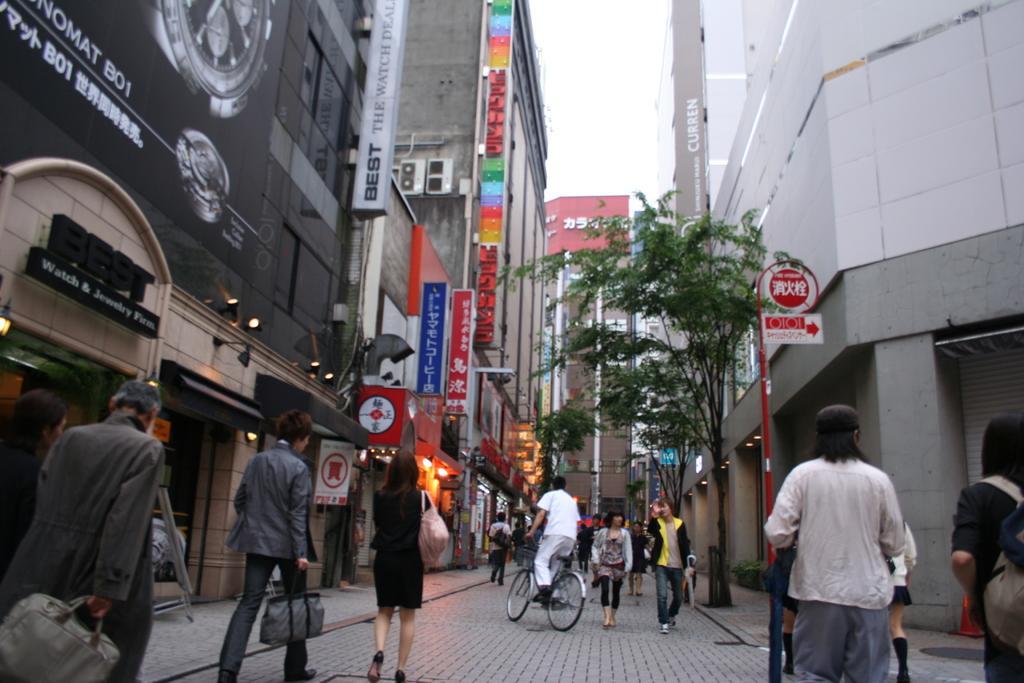In one or two sentences, can you explain what this image depicts? In this picture we can see a group of people on the ground, some people are wearing bags and some people are holding bags, one person is riding a bicycle, here we can see buildings, name boards, direction board, lights, trees, air conditioners and some objects we can see sky in the background. 